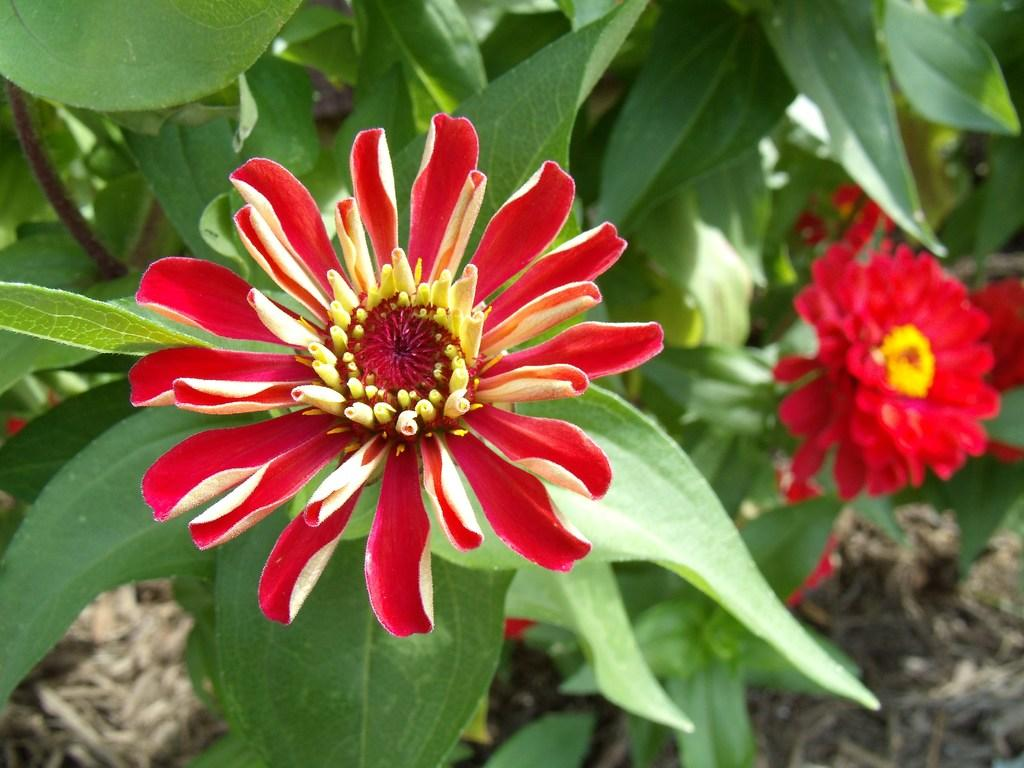What color are the flowers on the plant in the image? The flowers on the plant are red. What can be seen at the top of the plant? There are green leaves at the top of the plant. What type of vegetation is visible in the bottom right corner of the image? There is grass visible in the bottom right corner of the image. What type of coach can be seen in the background of the image? There is no coach visible in the image; it features a plant with red flowers and green leaves, along with grass in the bottom right corner. 